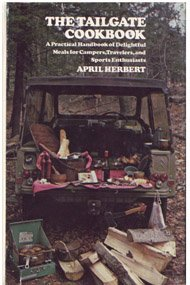Can you describe the setting shown on the cover of the book? The cover of the book features a tailgating scene with a rustic backdrop, illustrating a festively set tailgate of a vehicle with various dishes and utensils, surrounded by a forest-like environment. What types of dishes might be featured in this cookbook based on its setting and theme? The cookbook likely features hearty, portable dishes ideal for outdoor settings, such as grilled meats, easy-to-serve sides, and dishes that keep well outdoors, aligning with the ease and enjoyment of tailgating. 